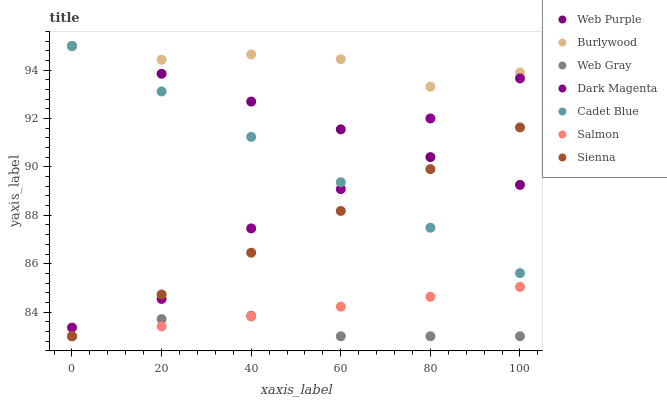Does Web Gray have the minimum area under the curve?
Answer yes or no. Yes. Does Burlywood have the maximum area under the curve?
Answer yes or no. Yes. Does Dark Magenta have the minimum area under the curve?
Answer yes or no. No. Does Dark Magenta have the maximum area under the curve?
Answer yes or no. No. Is Web Purple the smoothest?
Answer yes or no. Yes. Is Dark Magenta the roughest?
Answer yes or no. Yes. Is Burlywood the smoothest?
Answer yes or no. No. Is Burlywood the roughest?
Answer yes or no. No. Does Web Gray have the lowest value?
Answer yes or no. Yes. Does Dark Magenta have the lowest value?
Answer yes or no. No. Does Cadet Blue have the highest value?
Answer yes or no. Yes. Does Dark Magenta have the highest value?
Answer yes or no. No. Is Salmon less than Dark Magenta?
Answer yes or no. Yes. Is Burlywood greater than Sienna?
Answer yes or no. Yes. Does Cadet Blue intersect Dark Magenta?
Answer yes or no. Yes. Is Cadet Blue less than Dark Magenta?
Answer yes or no. No. Is Cadet Blue greater than Dark Magenta?
Answer yes or no. No. Does Salmon intersect Dark Magenta?
Answer yes or no. No. 